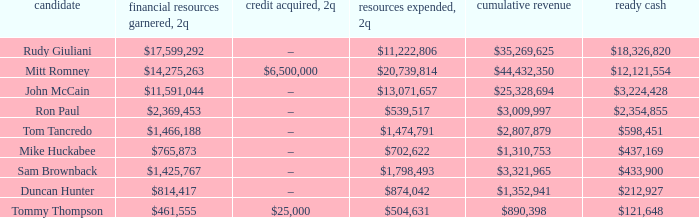Name the loans received for 2Q having total receipts of $25,328,694 –. 